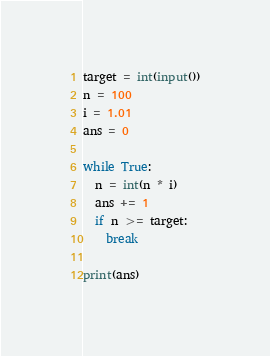<code> <loc_0><loc_0><loc_500><loc_500><_Python_>target = int(input())
n = 100
i = 1.01
ans = 0

while True:
  n = int(n * i)
  ans += 1
  if n >= target:
    break

print(ans)</code> 